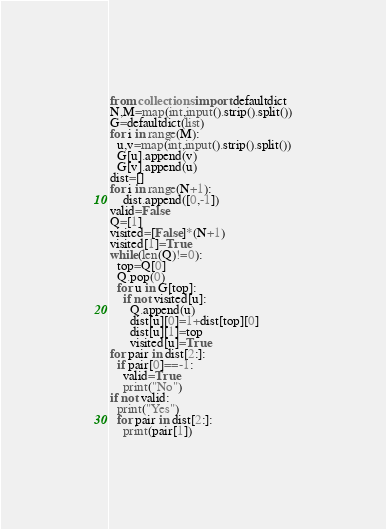<code> <loc_0><loc_0><loc_500><loc_500><_Python_>
from collections import defaultdict
N,M=map(int,input().strip().split())
G=defaultdict(list)
for i in range(M):
  u,v=map(int,input().strip().split())
  G[u].append(v)
  G[v].append(u)
dist=[]
for i in range(N+1):
    dist.append([0,-1])
valid=False
Q=[1]
visited=[False]*(N+1)
visited[1]=True
while(len(Q)!=0):
  top=Q[0]
  Q.pop(0)
  for u in G[top]:
    if not visited[u]:
      Q.append(u)
      dist[u][0]=1+dist[top][0]
      dist[u][1]=top
      visited[u]=True
for pair in dist[2:]:
  if pair[0]==-1:
    valid=True
    print("No")
if not valid:
  print("Yes")
  for pair in dist[2:]:
    print(pair[1])</code> 